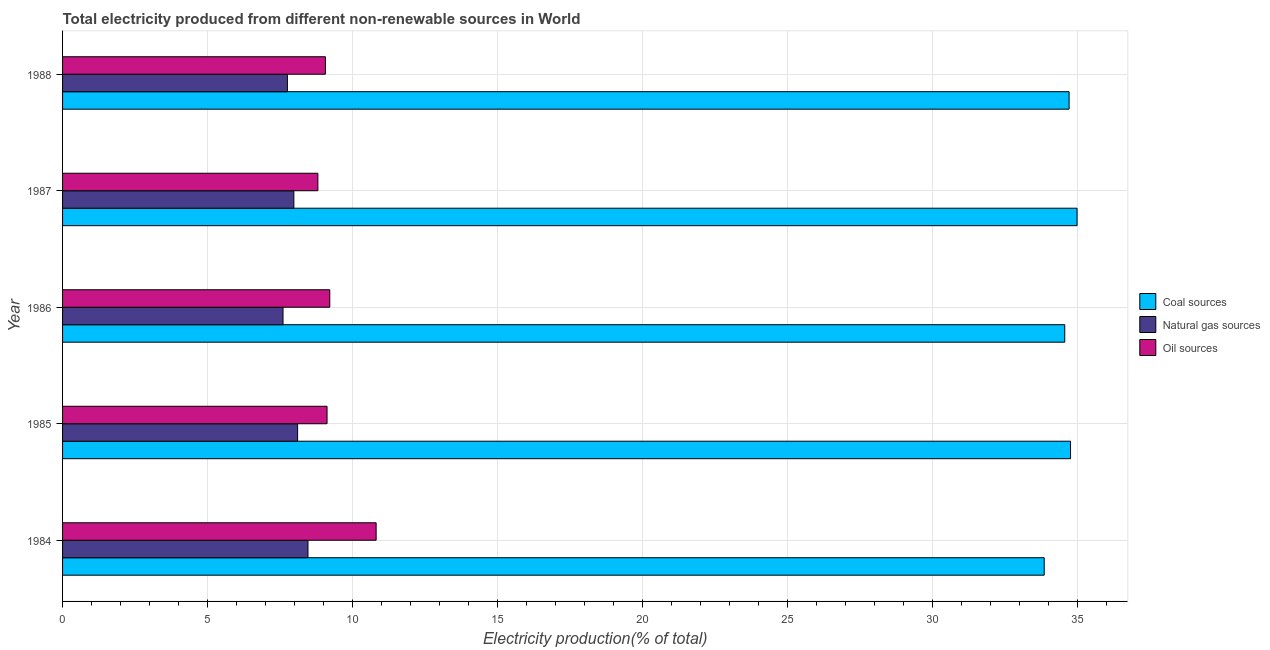How many different coloured bars are there?
Ensure brevity in your answer.  3. What is the label of the 4th group of bars from the top?
Your response must be concise. 1985. In how many cases, is the number of bars for a given year not equal to the number of legend labels?
Provide a succinct answer. 0. What is the percentage of electricity produced by oil sources in 1985?
Offer a very short reply. 9.12. Across all years, what is the maximum percentage of electricity produced by coal?
Offer a terse response. 34.99. Across all years, what is the minimum percentage of electricity produced by coal?
Offer a terse response. 33.85. In which year was the percentage of electricity produced by coal maximum?
Your response must be concise. 1987. What is the total percentage of electricity produced by natural gas in the graph?
Offer a terse response. 39.9. What is the difference between the percentage of electricity produced by oil sources in 1987 and that in 1988?
Your answer should be compact. -0.26. What is the difference between the percentage of electricity produced by coal in 1986 and the percentage of electricity produced by natural gas in 1987?
Keep it short and to the point. 26.58. What is the average percentage of electricity produced by coal per year?
Your answer should be compact. 34.57. In the year 1987, what is the difference between the percentage of electricity produced by coal and percentage of electricity produced by natural gas?
Give a very brief answer. 27.01. In how many years, is the percentage of electricity produced by coal greater than 32 %?
Give a very brief answer. 5. Is the percentage of electricity produced by oil sources in 1987 less than that in 1988?
Ensure brevity in your answer.  Yes. What is the difference between the highest and the second highest percentage of electricity produced by natural gas?
Your response must be concise. 0.36. What is the difference between the highest and the lowest percentage of electricity produced by oil sources?
Make the answer very short. 2.01. In how many years, is the percentage of electricity produced by coal greater than the average percentage of electricity produced by coal taken over all years?
Offer a terse response. 3. Is the sum of the percentage of electricity produced by coal in 1986 and 1988 greater than the maximum percentage of electricity produced by natural gas across all years?
Provide a short and direct response. Yes. What does the 2nd bar from the top in 1986 represents?
Your response must be concise. Natural gas sources. What does the 2nd bar from the bottom in 1984 represents?
Ensure brevity in your answer.  Natural gas sources. Is it the case that in every year, the sum of the percentage of electricity produced by coal and percentage of electricity produced by natural gas is greater than the percentage of electricity produced by oil sources?
Your answer should be very brief. Yes. How many years are there in the graph?
Keep it short and to the point. 5. Are the values on the major ticks of X-axis written in scientific E-notation?
Offer a terse response. No. Does the graph contain grids?
Provide a short and direct response. Yes. How many legend labels are there?
Keep it short and to the point. 3. How are the legend labels stacked?
Give a very brief answer. Vertical. What is the title of the graph?
Give a very brief answer. Total electricity produced from different non-renewable sources in World. What is the Electricity production(% of total) of Coal sources in 1984?
Offer a terse response. 33.85. What is the Electricity production(% of total) of Natural gas sources in 1984?
Your answer should be very brief. 8.46. What is the Electricity production(% of total) in Oil sources in 1984?
Provide a succinct answer. 10.81. What is the Electricity production(% of total) in Coal sources in 1985?
Keep it short and to the point. 34.76. What is the Electricity production(% of total) in Natural gas sources in 1985?
Make the answer very short. 8.11. What is the Electricity production(% of total) in Oil sources in 1985?
Give a very brief answer. 9.12. What is the Electricity production(% of total) of Coal sources in 1986?
Make the answer very short. 34.56. What is the Electricity production(% of total) of Natural gas sources in 1986?
Make the answer very short. 7.6. What is the Electricity production(% of total) of Oil sources in 1986?
Offer a terse response. 9.21. What is the Electricity production(% of total) in Coal sources in 1987?
Give a very brief answer. 34.99. What is the Electricity production(% of total) in Natural gas sources in 1987?
Provide a succinct answer. 7.98. What is the Electricity production(% of total) in Oil sources in 1987?
Offer a very short reply. 8.8. What is the Electricity production(% of total) in Coal sources in 1988?
Your answer should be compact. 34.71. What is the Electricity production(% of total) of Natural gas sources in 1988?
Offer a very short reply. 7.75. What is the Electricity production(% of total) of Oil sources in 1988?
Give a very brief answer. 9.06. Across all years, what is the maximum Electricity production(% of total) in Coal sources?
Your answer should be very brief. 34.99. Across all years, what is the maximum Electricity production(% of total) of Natural gas sources?
Offer a terse response. 8.46. Across all years, what is the maximum Electricity production(% of total) in Oil sources?
Give a very brief answer. 10.81. Across all years, what is the minimum Electricity production(% of total) of Coal sources?
Make the answer very short. 33.85. Across all years, what is the minimum Electricity production(% of total) in Natural gas sources?
Keep it short and to the point. 7.6. Across all years, what is the minimum Electricity production(% of total) in Oil sources?
Make the answer very short. 8.8. What is the total Electricity production(% of total) in Coal sources in the graph?
Offer a very short reply. 172.87. What is the total Electricity production(% of total) in Natural gas sources in the graph?
Offer a very short reply. 39.9. What is the total Electricity production(% of total) of Oil sources in the graph?
Keep it short and to the point. 47.02. What is the difference between the Electricity production(% of total) in Coal sources in 1984 and that in 1985?
Your response must be concise. -0.91. What is the difference between the Electricity production(% of total) in Natural gas sources in 1984 and that in 1985?
Keep it short and to the point. 0.36. What is the difference between the Electricity production(% of total) in Oil sources in 1984 and that in 1985?
Provide a succinct answer. 1.69. What is the difference between the Electricity production(% of total) in Coal sources in 1984 and that in 1986?
Your answer should be very brief. -0.71. What is the difference between the Electricity production(% of total) of Natural gas sources in 1984 and that in 1986?
Offer a very short reply. 0.86. What is the difference between the Electricity production(% of total) of Oil sources in 1984 and that in 1986?
Make the answer very short. 1.6. What is the difference between the Electricity production(% of total) in Coal sources in 1984 and that in 1987?
Your response must be concise. -1.13. What is the difference between the Electricity production(% of total) of Natural gas sources in 1984 and that in 1987?
Your answer should be very brief. 0.49. What is the difference between the Electricity production(% of total) in Oil sources in 1984 and that in 1987?
Make the answer very short. 2.01. What is the difference between the Electricity production(% of total) in Coal sources in 1984 and that in 1988?
Your response must be concise. -0.86. What is the difference between the Electricity production(% of total) in Natural gas sources in 1984 and that in 1988?
Your response must be concise. 0.71. What is the difference between the Electricity production(% of total) in Oil sources in 1984 and that in 1988?
Provide a succinct answer. 1.75. What is the difference between the Electricity production(% of total) in Coal sources in 1985 and that in 1986?
Your response must be concise. 0.2. What is the difference between the Electricity production(% of total) in Natural gas sources in 1985 and that in 1986?
Your answer should be compact. 0.5. What is the difference between the Electricity production(% of total) of Oil sources in 1985 and that in 1986?
Provide a succinct answer. -0.09. What is the difference between the Electricity production(% of total) of Coal sources in 1985 and that in 1987?
Make the answer very short. -0.23. What is the difference between the Electricity production(% of total) of Natural gas sources in 1985 and that in 1987?
Provide a short and direct response. 0.13. What is the difference between the Electricity production(% of total) in Oil sources in 1985 and that in 1987?
Your response must be concise. 0.32. What is the difference between the Electricity production(% of total) in Coal sources in 1985 and that in 1988?
Your answer should be compact. 0.05. What is the difference between the Electricity production(% of total) of Natural gas sources in 1985 and that in 1988?
Offer a very short reply. 0.35. What is the difference between the Electricity production(% of total) in Oil sources in 1985 and that in 1988?
Offer a terse response. 0.06. What is the difference between the Electricity production(% of total) in Coal sources in 1986 and that in 1987?
Offer a very short reply. -0.42. What is the difference between the Electricity production(% of total) of Natural gas sources in 1986 and that in 1987?
Your answer should be compact. -0.37. What is the difference between the Electricity production(% of total) of Oil sources in 1986 and that in 1987?
Your answer should be compact. 0.41. What is the difference between the Electricity production(% of total) in Coal sources in 1986 and that in 1988?
Keep it short and to the point. -0.15. What is the difference between the Electricity production(% of total) of Natural gas sources in 1986 and that in 1988?
Keep it short and to the point. -0.15. What is the difference between the Electricity production(% of total) in Oil sources in 1986 and that in 1988?
Provide a short and direct response. 0.15. What is the difference between the Electricity production(% of total) of Coal sources in 1987 and that in 1988?
Keep it short and to the point. 0.27. What is the difference between the Electricity production(% of total) in Natural gas sources in 1987 and that in 1988?
Give a very brief answer. 0.22. What is the difference between the Electricity production(% of total) in Oil sources in 1987 and that in 1988?
Make the answer very short. -0.26. What is the difference between the Electricity production(% of total) in Coal sources in 1984 and the Electricity production(% of total) in Natural gas sources in 1985?
Offer a very short reply. 25.75. What is the difference between the Electricity production(% of total) of Coal sources in 1984 and the Electricity production(% of total) of Oil sources in 1985?
Keep it short and to the point. 24.73. What is the difference between the Electricity production(% of total) of Natural gas sources in 1984 and the Electricity production(% of total) of Oil sources in 1985?
Make the answer very short. -0.66. What is the difference between the Electricity production(% of total) in Coal sources in 1984 and the Electricity production(% of total) in Natural gas sources in 1986?
Ensure brevity in your answer.  26.25. What is the difference between the Electricity production(% of total) of Coal sources in 1984 and the Electricity production(% of total) of Oil sources in 1986?
Provide a succinct answer. 24.64. What is the difference between the Electricity production(% of total) in Natural gas sources in 1984 and the Electricity production(% of total) in Oil sources in 1986?
Give a very brief answer. -0.75. What is the difference between the Electricity production(% of total) in Coal sources in 1984 and the Electricity production(% of total) in Natural gas sources in 1987?
Provide a short and direct response. 25.88. What is the difference between the Electricity production(% of total) in Coal sources in 1984 and the Electricity production(% of total) in Oil sources in 1987?
Keep it short and to the point. 25.05. What is the difference between the Electricity production(% of total) in Natural gas sources in 1984 and the Electricity production(% of total) in Oil sources in 1987?
Your answer should be compact. -0.34. What is the difference between the Electricity production(% of total) in Coal sources in 1984 and the Electricity production(% of total) in Natural gas sources in 1988?
Your answer should be compact. 26.1. What is the difference between the Electricity production(% of total) of Coal sources in 1984 and the Electricity production(% of total) of Oil sources in 1988?
Offer a very short reply. 24.79. What is the difference between the Electricity production(% of total) of Natural gas sources in 1984 and the Electricity production(% of total) of Oil sources in 1988?
Your answer should be compact. -0.6. What is the difference between the Electricity production(% of total) in Coal sources in 1985 and the Electricity production(% of total) in Natural gas sources in 1986?
Offer a terse response. 27.16. What is the difference between the Electricity production(% of total) in Coal sources in 1985 and the Electricity production(% of total) in Oil sources in 1986?
Your answer should be very brief. 25.55. What is the difference between the Electricity production(% of total) of Natural gas sources in 1985 and the Electricity production(% of total) of Oil sources in 1986?
Offer a very short reply. -1.11. What is the difference between the Electricity production(% of total) in Coal sources in 1985 and the Electricity production(% of total) in Natural gas sources in 1987?
Make the answer very short. 26.78. What is the difference between the Electricity production(% of total) in Coal sources in 1985 and the Electricity production(% of total) in Oil sources in 1987?
Your response must be concise. 25.96. What is the difference between the Electricity production(% of total) in Natural gas sources in 1985 and the Electricity production(% of total) in Oil sources in 1987?
Make the answer very short. -0.7. What is the difference between the Electricity production(% of total) in Coal sources in 1985 and the Electricity production(% of total) in Natural gas sources in 1988?
Ensure brevity in your answer.  27.01. What is the difference between the Electricity production(% of total) of Coal sources in 1985 and the Electricity production(% of total) of Oil sources in 1988?
Offer a very short reply. 25.7. What is the difference between the Electricity production(% of total) of Natural gas sources in 1985 and the Electricity production(% of total) of Oil sources in 1988?
Ensure brevity in your answer.  -0.96. What is the difference between the Electricity production(% of total) of Coal sources in 1986 and the Electricity production(% of total) of Natural gas sources in 1987?
Your response must be concise. 26.58. What is the difference between the Electricity production(% of total) of Coal sources in 1986 and the Electricity production(% of total) of Oil sources in 1987?
Provide a short and direct response. 25.76. What is the difference between the Electricity production(% of total) in Natural gas sources in 1986 and the Electricity production(% of total) in Oil sources in 1987?
Offer a very short reply. -1.2. What is the difference between the Electricity production(% of total) of Coal sources in 1986 and the Electricity production(% of total) of Natural gas sources in 1988?
Your answer should be very brief. 26.81. What is the difference between the Electricity production(% of total) in Coal sources in 1986 and the Electricity production(% of total) in Oil sources in 1988?
Offer a very short reply. 25.5. What is the difference between the Electricity production(% of total) in Natural gas sources in 1986 and the Electricity production(% of total) in Oil sources in 1988?
Offer a terse response. -1.46. What is the difference between the Electricity production(% of total) in Coal sources in 1987 and the Electricity production(% of total) in Natural gas sources in 1988?
Give a very brief answer. 27.23. What is the difference between the Electricity production(% of total) of Coal sources in 1987 and the Electricity production(% of total) of Oil sources in 1988?
Your response must be concise. 25.92. What is the difference between the Electricity production(% of total) of Natural gas sources in 1987 and the Electricity production(% of total) of Oil sources in 1988?
Keep it short and to the point. -1.09. What is the average Electricity production(% of total) of Coal sources per year?
Provide a short and direct response. 34.57. What is the average Electricity production(% of total) of Natural gas sources per year?
Your answer should be very brief. 7.98. What is the average Electricity production(% of total) in Oil sources per year?
Offer a terse response. 9.4. In the year 1984, what is the difference between the Electricity production(% of total) of Coal sources and Electricity production(% of total) of Natural gas sources?
Your answer should be compact. 25.39. In the year 1984, what is the difference between the Electricity production(% of total) in Coal sources and Electricity production(% of total) in Oil sources?
Give a very brief answer. 23.04. In the year 1984, what is the difference between the Electricity production(% of total) in Natural gas sources and Electricity production(% of total) in Oil sources?
Give a very brief answer. -2.35. In the year 1985, what is the difference between the Electricity production(% of total) in Coal sources and Electricity production(% of total) in Natural gas sources?
Keep it short and to the point. 26.65. In the year 1985, what is the difference between the Electricity production(% of total) of Coal sources and Electricity production(% of total) of Oil sources?
Your response must be concise. 25.64. In the year 1985, what is the difference between the Electricity production(% of total) of Natural gas sources and Electricity production(% of total) of Oil sources?
Give a very brief answer. -1.02. In the year 1986, what is the difference between the Electricity production(% of total) in Coal sources and Electricity production(% of total) in Natural gas sources?
Provide a short and direct response. 26.96. In the year 1986, what is the difference between the Electricity production(% of total) of Coal sources and Electricity production(% of total) of Oil sources?
Ensure brevity in your answer.  25.35. In the year 1986, what is the difference between the Electricity production(% of total) in Natural gas sources and Electricity production(% of total) in Oil sources?
Offer a very short reply. -1.61. In the year 1987, what is the difference between the Electricity production(% of total) of Coal sources and Electricity production(% of total) of Natural gas sources?
Keep it short and to the point. 27.01. In the year 1987, what is the difference between the Electricity production(% of total) in Coal sources and Electricity production(% of total) in Oil sources?
Offer a terse response. 26.18. In the year 1987, what is the difference between the Electricity production(% of total) in Natural gas sources and Electricity production(% of total) in Oil sources?
Offer a very short reply. -0.83. In the year 1988, what is the difference between the Electricity production(% of total) in Coal sources and Electricity production(% of total) in Natural gas sources?
Provide a succinct answer. 26.96. In the year 1988, what is the difference between the Electricity production(% of total) of Coal sources and Electricity production(% of total) of Oil sources?
Ensure brevity in your answer.  25.65. In the year 1988, what is the difference between the Electricity production(% of total) in Natural gas sources and Electricity production(% of total) in Oil sources?
Ensure brevity in your answer.  -1.31. What is the ratio of the Electricity production(% of total) in Coal sources in 1984 to that in 1985?
Offer a very short reply. 0.97. What is the ratio of the Electricity production(% of total) in Natural gas sources in 1984 to that in 1985?
Keep it short and to the point. 1.04. What is the ratio of the Electricity production(% of total) in Oil sources in 1984 to that in 1985?
Your answer should be very brief. 1.19. What is the ratio of the Electricity production(% of total) in Coal sources in 1984 to that in 1986?
Provide a short and direct response. 0.98. What is the ratio of the Electricity production(% of total) of Natural gas sources in 1984 to that in 1986?
Your answer should be very brief. 1.11. What is the ratio of the Electricity production(% of total) of Oil sources in 1984 to that in 1986?
Provide a short and direct response. 1.17. What is the ratio of the Electricity production(% of total) of Coal sources in 1984 to that in 1987?
Your answer should be compact. 0.97. What is the ratio of the Electricity production(% of total) of Natural gas sources in 1984 to that in 1987?
Your answer should be compact. 1.06. What is the ratio of the Electricity production(% of total) of Oil sources in 1984 to that in 1987?
Your answer should be very brief. 1.23. What is the ratio of the Electricity production(% of total) in Coal sources in 1984 to that in 1988?
Offer a very short reply. 0.98. What is the ratio of the Electricity production(% of total) of Natural gas sources in 1984 to that in 1988?
Ensure brevity in your answer.  1.09. What is the ratio of the Electricity production(% of total) of Oil sources in 1984 to that in 1988?
Make the answer very short. 1.19. What is the ratio of the Electricity production(% of total) of Coal sources in 1985 to that in 1986?
Provide a succinct answer. 1.01. What is the ratio of the Electricity production(% of total) in Natural gas sources in 1985 to that in 1986?
Your response must be concise. 1.07. What is the ratio of the Electricity production(% of total) in Oil sources in 1985 to that in 1986?
Ensure brevity in your answer.  0.99. What is the ratio of the Electricity production(% of total) of Natural gas sources in 1985 to that in 1987?
Make the answer very short. 1.02. What is the ratio of the Electricity production(% of total) of Oil sources in 1985 to that in 1987?
Provide a short and direct response. 1.04. What is the ratio of the Electricity production(% of total) of Natural gas sources in 1985 to that in 1988?
Your answer should be compact. 1.05. What is the ratio of the Electricity production(% of total) of Oil sources in 1985 to that in 1988?
Your answer should be very brief. 1.01. What is the ratio of the Electricity production(% of total) of Coal sources in 1986 to that in 1987?
Offer a very short reply. 0.99. What is the ratio of the Electricity production(% of total) in Natural gas sources in 1986 to that in 1987?
Provide a succinct answer. 0.95. What is the ratio of the Electricity production(% of total) in Oil sources in 1986 to that in 1987?
Keep it short and to the point. 1.05. What is the ratio of the Electricity production(% of total) in Coal sources in 1986 to that in 1988?
Your response must be concise. 1. What is the ratio of the Electricity production(% of total) of Natural gas sources in 1986 to that in 1988?
Your response must be concise. 0.98. What is the ratio of the Electricity production(% of total) of Oil sources in 1986 to that in 1988?
Your answer should be very brief. 1.02. What is the ratio of the Electricity production(% of total) in Coal sources in 1987 to that in 1988?
Ensure brevity in your answer.  1.01. What is the ratio of the Electricity production(% of total) of Natural gas sources in 1987 to that in 1988?
Make the answer very short. 1.03. What is the ratio of the Electricity production(% of total) in Oil sources in 1987 to that in 1988?
Offer a terse response. 0.97. What is the difference between the highest and the second highest Electricity production(% of total) of Coal sources?
Your answer should be compact. 0.23. What is the difference between the highest and the second highest Electricity production(% of total) in Natural gas sources?
Provide a short and direct response. 0.36. What is the difference between the highest and the second highest Electricity production(% of total) of Oil sources?
Provide a short and direct response. 1.6. What is the difference between the highest and the lowest Electricity production(% of total) in Coal sources?
Your answer should be very brief. 1.13. What is the difference between the highest and the lowest Electricity production(% of total) of Natural gas sources?
Make the answer very short. 0.86. What is the difference between the highest and the lowest Electricity production(% of total) of Oil sources?
Provide a short and direct response. 2.01. 